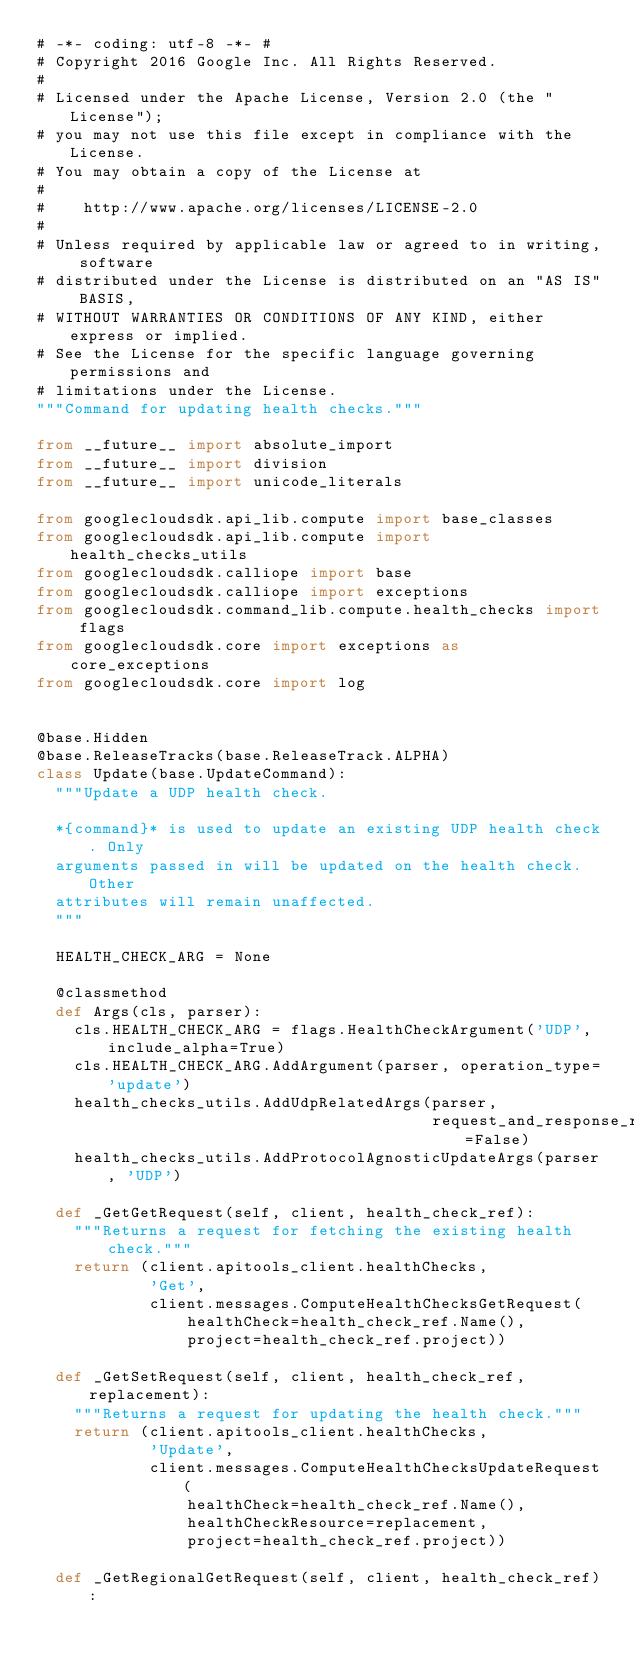Convert code to text. <code><loc_0><loc_0><loc_500><loc_500><_Python_># -*- coding: utf-8 -*- #
# Copyright 2016 Google Inc. All Rights Reserved.
#
# Licensed under the Apache License, Version 2.0 (the "License");
# you may not use this file except in compliance with the License.
# You may obtain a copy of the License at
#
#    http://www.apache.org/licenses/LICENSE-2.0
#
# Unless required by applicable law or agreed to in writing, software
# distributed under the License is distributed on an "AS IS" BASIS,
# WITHOUT WARRANTIES OR CONDITIONS OF ANY KIND, either express or implied.
# See the License for the specific language governing permissions and
# limitations under the License.
"""Command for updating health checks."""

from __future__ import absolute_import
from __future__ import division
from __future__ import unicode_literals

from googlecloudsdk.api_lib.compute import base_classes
from googlecloudsdk.api_lib.compute import health_checks_utils
from googlecloudsdk.calliope import base
from googlecloudsdk.calliope import exceptions
from googlecloudsdk.command_lib.compute.health_checks import flags
from googlecloudsdk.core import exceptions as core_exceptions
from googlecloudsdk.core import log


@base.Hidden
@base.ReleaseTracks(base.ReleaseTrack.ALPHA)
class Update(base.UpdateCommand):
  """Update a UDP health check.

  *{command}* is used to update an existing UDP health check. Only
  arguments passed in will be updated on the health check. Other
  attributes will remain unaffected.
  """

  HEALTH_CHECK_ARG = None

  @classmethod
  def Args(cls, parser):
    cls.HEALTH_CHECK_ARG = flags.HealthCheckArgument('UDP', include_alpha=True)
    cls.HEALTH_CHECK_ARG.AddArgument(parser, operation_type='update')
    health_checks_utils.AddUdpRelatedArgs(parser,
                                          request_and_response_required=False)
    health_checks_utils.AddProtocolAgnosticUpdateArgs(parser, 'UDP')

  def _GetGetRequest(self, client, health_check_ref):
    """Returns a request for fetching the existing health check."""
    return (client.apitools_client.healthChecks,
            'Get',
            client.messages.ComputeHealthChecksGetRequest(
                healthCheck=health_check_ref.Name(),
                project=health_check_ref.project))

  def _GetSetRequest(self, client, health_check_ref, replacement):
    """Returns a request for updating the health check."""
    return (client.apitools_client.healthChecks,
            'Update',
            client.messages.ComputeHealthChecksUpdateRequest(
                healthCheck=health_check_ref.Name(),
                healthCheckResource=replacement,
                project=health_check_ref.project))

  def _GetRegionalGetRequest(self, client, health_check_ref):</code> 